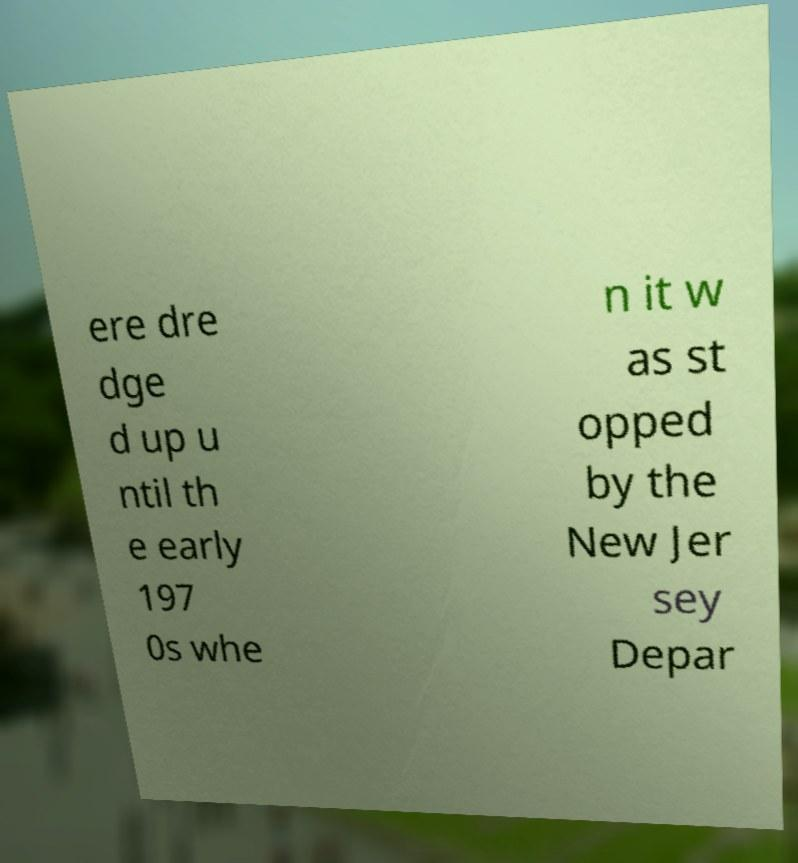Please read and relay the text visible in this image. What does it say? ere dre dge d up u ntil th e early 197 0s whe n it w as st opped by the New Jer sey Depar 